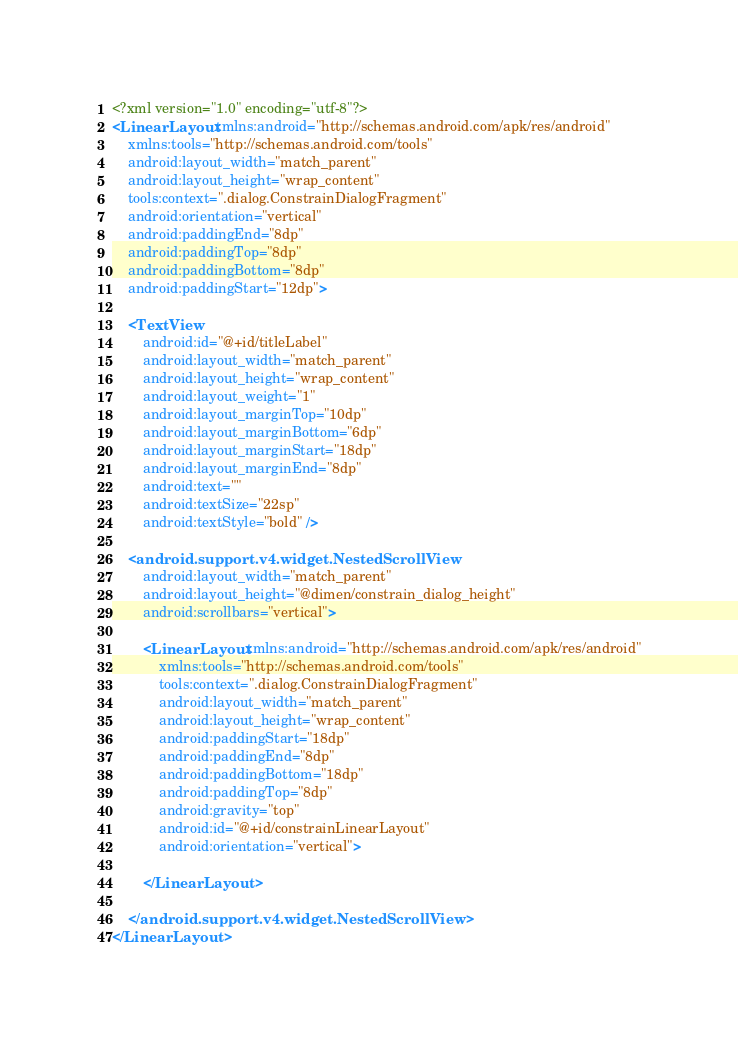Convert code to text. <code><loc_0><loc_0><loc_500><loc_500><_XML_><?xml version="1.0" encoding="utf-8"?>
<LinearLayout xmlns:android="http://schemas.android.com/apk/res/android"
    xmlns:tools="http://schemas.android.com/tools"
    android:layout_width="match_parent"
    android:layout_height="wrap_content"
    tools:context=".dialog.ConstrainDialogFragment"
    android:orientation="vertical"
    android:paddingEnd="8dp"
    android:paddingTop="8dp"
    android:paddingBottom="8dp"
    android:paddingStart="12dp">

    <TextView
        android:id="@+id/titleLabel"
        android:layout_width="match_parent"
        android:layout_height="wrap_content"
        android:layout_weight="1"
        android:layout_marginTop="10dp"
        android:layout_marginBottom="6dp"
        android:layout_marginStart="18dp"
        android:layout_marginEnd="8dp"
        android:text=""
        android:textSize="22sp"
        android:textStyle="bold" />

    <android.support.v4.widget.NestedScrollView
        android:layout_width="match_parent"
        android:layout_height="@dimen/constrain_dialog_height"
        android:scrollbars="vertical">

        <LinearLayout xmlns:android="http://schemas.android.com/apk/res/android"
            xmlns:tools="http://schemas.android.com/tools"
            tools:context=".dialog.ConstrainDialogFragment"
            android:layout_width="match_parent"
            android:layout_height="wrap_content"
            android:paddingStart="18dp"
            android:paddingEnd="8dp"
            android:paddingBottom="18dp"
            android:paddingTop="8dp"
            android:gravity="top"
            android:id="@+id/constrainLinearLayout"
            android:orientation="vertical">

        </LinearLayout>

    </android.support.v4.widget.NestedScrollView>
</LinearLayout></code> 